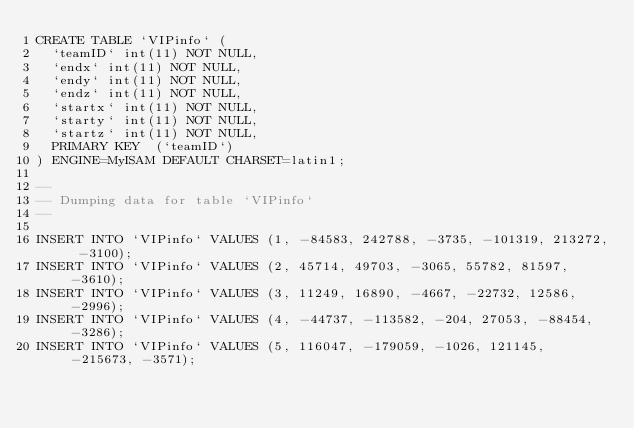Convert code to text. <code><loc_0><loc_0><loc_500><loc_500><_SQL_>CREATE TABLE `VIPinfo` (
  `teamID` int(11) NOT NULL,
  `endx` int(11) NOT NULL,
  `endy` int(11) NOT NULL,
  `endz` int(11) NOT NULL,
  `startx` int(11) NOT NULL,
  `starty` int(11) NOT NULL,
  `startz` int(11) NOT NULL,
  PRIMARY KEY  (`teamID`)
) ENGINE=MyISAM DEFAULT CHARSET=latin1;

-- 
-- Dumping data for table `VIPinfo`
-- 

INSERT INTO `VIPinfo` VALUES (1, -84583, 242788, -3735, -101319, 213272, -3100);
INSERT INTO `VIPinfo` VALUES (2, 45714, 49703, -3065, 55782, 81597, -3610);
INSERT INTO `VIPinfo` VALUES (3, 11249, 16890, -4667, -22732, 12586, -2996);
INSERT INTO `VIPinfo` VALUES (4, -44737, -113582, -204, 27053, -88454, -3286);
INSERT INTO `VIPinfo` VALUES (5, 116047, -179059, -1026, 121145, -215673, -3571);
</code> 